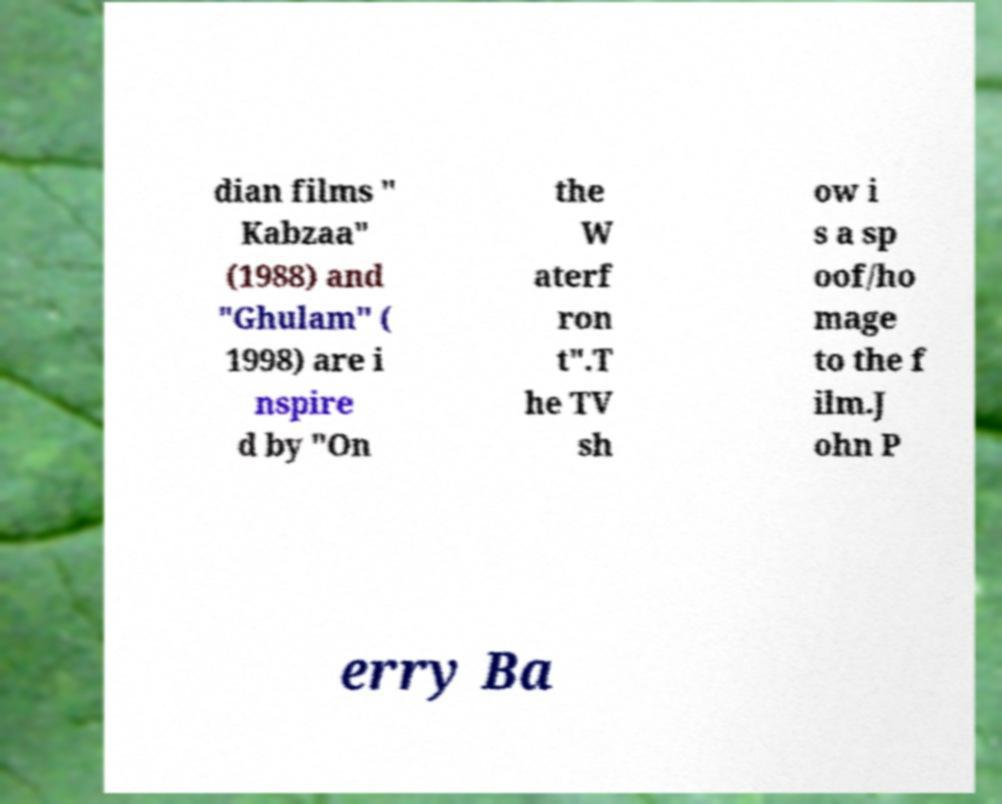I need the written content from this picture converted into text. Can you do that? dian films " Kabzaa" (1988) and "Ghulam" ( 1998) are i nspire d by "On the W aterf ron t".T he TV sh ow i s a sp oof/ho mage to the f ilm.J ohn P erry Ba 